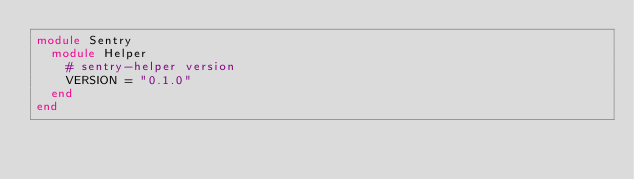Convert code to text. <code><loc_0><loc_0><loc_500><loc_500><_Ruby_>module Sentry
  module Helper
    # sentry-helper version
    VERSION = "0.1.0"
  end
end
</code> 